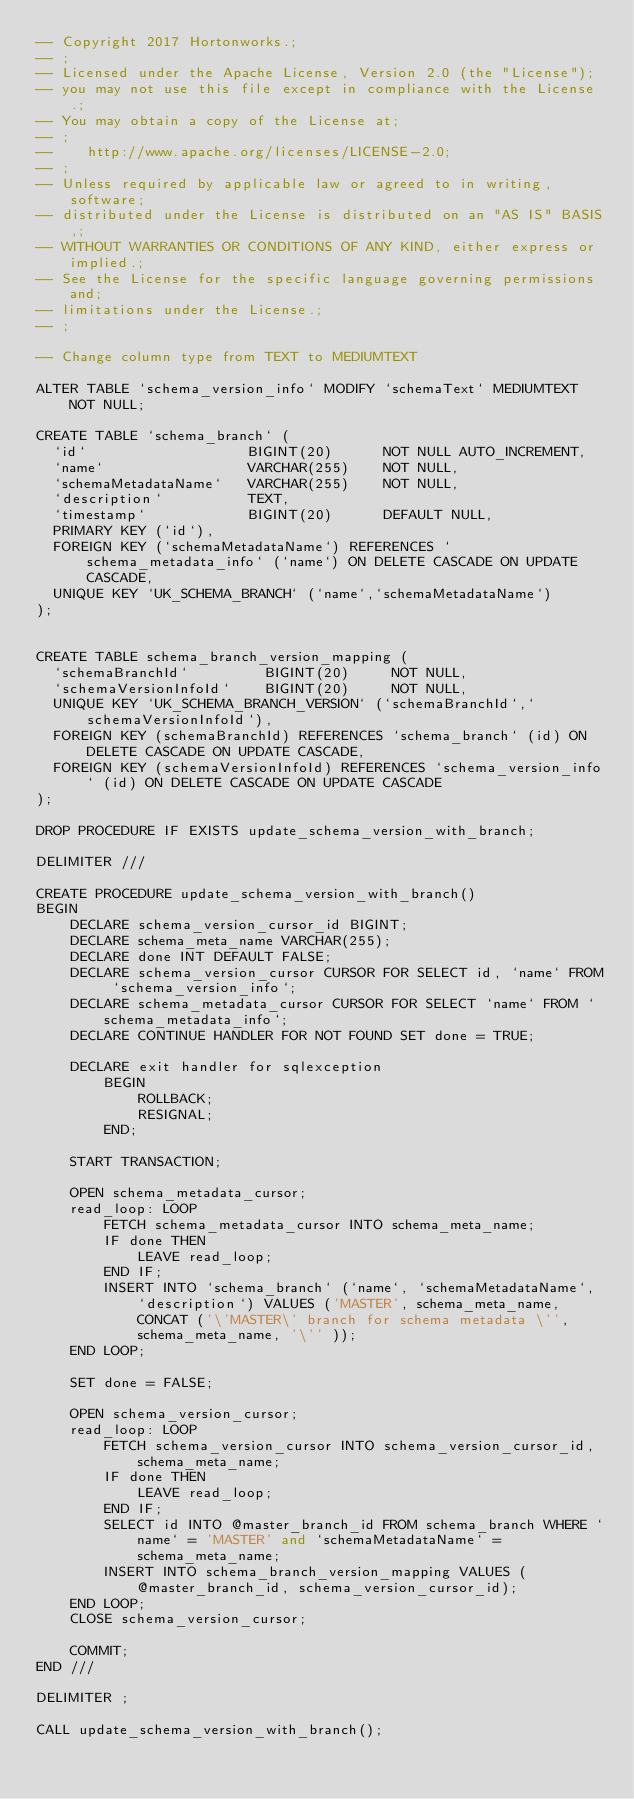<code> <loc_0><loc_0><loc_500><loc_500><_SQL_>-- Copyright 2017 Hortonworks.;
-- ;
-- Licensed under the Apache License, Version 2.0 (the "License");
-- you may not use this file except in compliance with the License.;
-- You may obtain a copy of the License at;
-- ;
--    http://www.apache.org/licenses/LICENSE-2.0;
-- ;
-- Unless required by applicable law or agreed to in writing, software;
-- distributed under the License is distributed on an "AS IS" BASIS,;
-- WITHOUT WARRANTIES OR CONDITIONS OF ANY KIND, either express or implied.;
-- See the License for the specific language governing permissions and;
-- limitations under the License.;
-- ;

-- Change column type from TEXT to MEDIUMTEXT

ALTER TABLE `schema_version_info` MODIFY `schemaText` MEDIUMTEXT NOT NULL;

CREATE TABLE `schema_branch` (
  `id`                   BIGINT(20)      NOT NULL AUTO_INCREMENT,
  `name`                 VARCHAR(255)    NOT NULL,
  `schemaMetadataName`   VARCHAR(255)    NOT NULL,
  `description`          TEXT,
  `timestamp`            BIGINT(20)      DEFAULT NULL,
  PRIMARY KEY (`id`),
  FOREIGN KEY (`schemaMetadataName`) REFERENCES `schema_metadata_info` (`name`) ON DELETE CASCADE ON UPDATE CASCADE,
  UNIQUE KEY `UK_SCHEMA_BRANCH` (`name`,`schemaMetadataName`)
);


CREATE TABLE schema_branch_version_mapping (
  `schemaBranchId`         BIGINT(20)     NOT NULL,
  `schemaVersionInfoId`    BIGINT(20)     NOT NULL,
  UNIQUE KEY `UK_SCHEMA_BRANCH_VERSION` (`schemaBranchId`,`schemaVersionInfoId`),
  FOREIGN KEY (schemaBranchId) REFERENCES `schema_branch` (id) ON DELETE CASCADE ON UPDATE CASCADE,
  FOREIGN KEY (schemaVersionInfoId) REFERENCES `schema_version_info` (id) ON DELETE CASCADE ON UPDATE CASCADE
);

DROP PROCEDURE IF EXISTS update_schema_version_with_branch;

DELIMITER ///

CREATE PROCEDURE update_schema_version_with_branch()
BEGIN
    DECLARE schema_version_cursor_id BIGINT;
    DECLARE schema_meta_name VARCHAR(255);
    DECLARE done INT DEFAULT FALSE;
    DECLARE schema_version_cursor CURSOR FOR SELECT id, `name` FROM `schema_version_info`;
    DECLARE schema_metadata_cursor CURSOR FOR SELECT `name` FROM `schema_metadata_info`;
    DECLARE CONTINUE HANDLER FOR NOT FOUND SET done = TRUE;

    DECLARE exit handler for sqlexception
        BEGIN
            ROLLBACK;
            RESIGNAL;
        END;

    START TRANSACTION;

    OPEN schema_metadata_cursor;
    read_loop: LOOP
        FETCH schema_metadata_cursor INTO schema_meta_name;
        IF done THEN
            LEAVE read_loop;
        END IF;
        INSERT INTO `schema_branch` (`name`, `schemaMetadataName`, `description`) VALUES ('MASTER', schema_meta_name, CONCAT ('\'MASTER\' branch for schema metadata \'', schema_meta_name, '\'' ));
    END LOOP;

    SET done = FALSE;

    OPEN schema_version_cursor;
    read_loop: LOOP
        FETCH schema_version_cursor INTO schema_version_cursor_id, schema_meta_name;
        IF done THEN
            LEAVE read_loop;
        END IF;
        SELECT id INTO @master_branch_id FROM schema_branch WHERE `name` = 'MASTER' and `schemaMetadataName` = schema_meta_name;
        INSERT INTO schema_branch_version_mapping VALUES (@master_branch_id, schema_version_cursor_id);
    END LOOP;
    CLOSE schema_version_cursor;

    COMMIT;
END ///

DELIMITER ;

CALL update_schema_version_with_branch();










</code> 